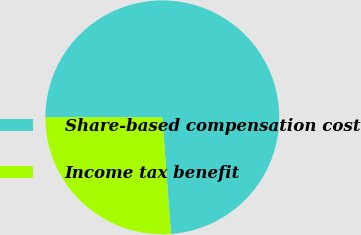<chart> <loc_0><loc_0><loc_500><loc_500><pie_chart><fcel>Share-based compensation cost<fcel>Income tax benefit<nl><fcel>73.8%<fcel>26.2%<nl></chart> 